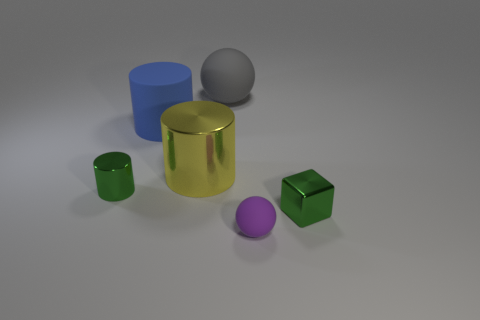Subtract all tiny green metallic cylinders. How many cylinders are left? 2 Add 2 big yellow cylinders. How many objects exist? 8 Subtract 1 cubes. How many cubes are left? 0 Subtract all blue cylinders. How many cylinders are left? 2 Subtract all cyan blocks. How many brown balls are left? 0 Subtract all big gray balls. Subtract all blue matte objects. How many objects are left? 4 Add 4 large blue things. How many large blue things are left? 5 Add 4 green metal cubes. How many green metal cubes exist? 5 Subtract 0 yellow blocks. How many objects are left? 6 Subtract all cubes. How many objects are left? 5 